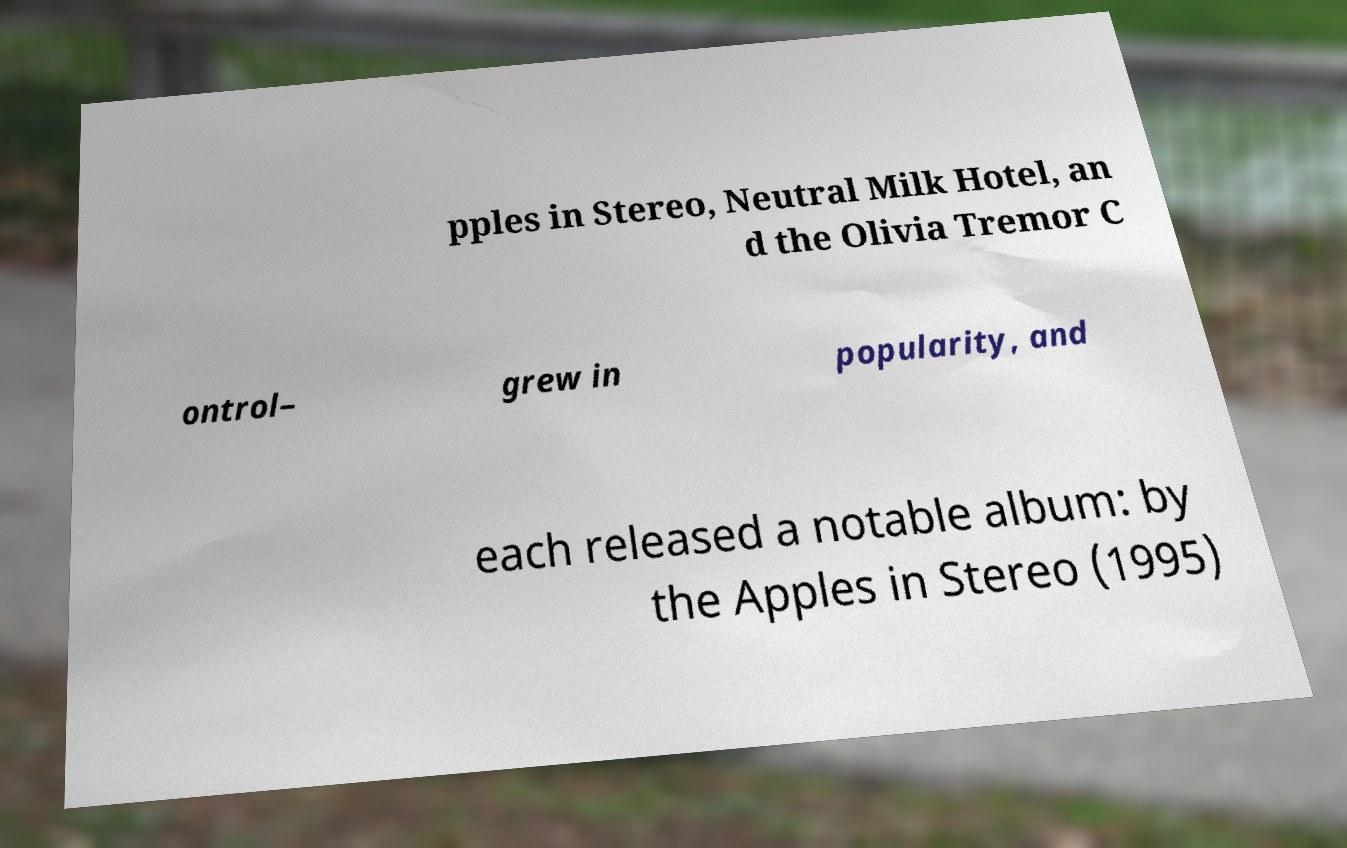There's text embedded in this image that I need extracted. Can you transcribe it verbatim? pples in Stereo, Neutral Milk Hotel, an d the Olivia Tremor C ontrol– grew in popularity, and each released a notable album: by the Apples in Stereo (1995) 